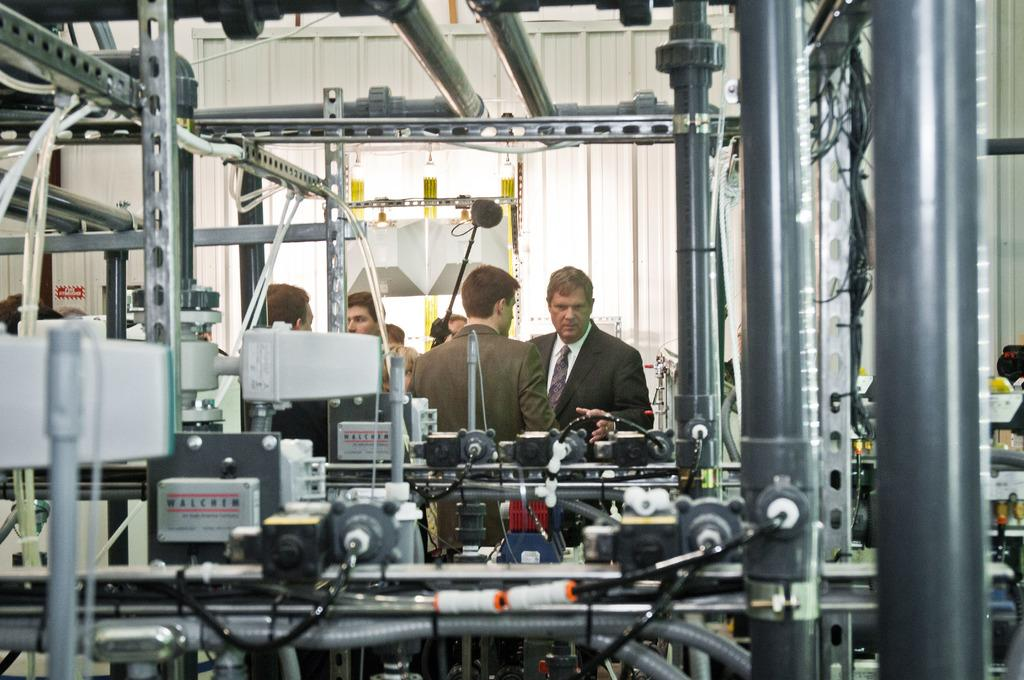How many people are in the image? There are persons standing in the image. What is the surface on which the persons are standing? The persons are standing on the floor. What else can be seen in the image besides the persons? There are machines in the image. What type of berry is being picked by the woman in the image? There is no woman or berry present in the image; it only features persons and machines. 